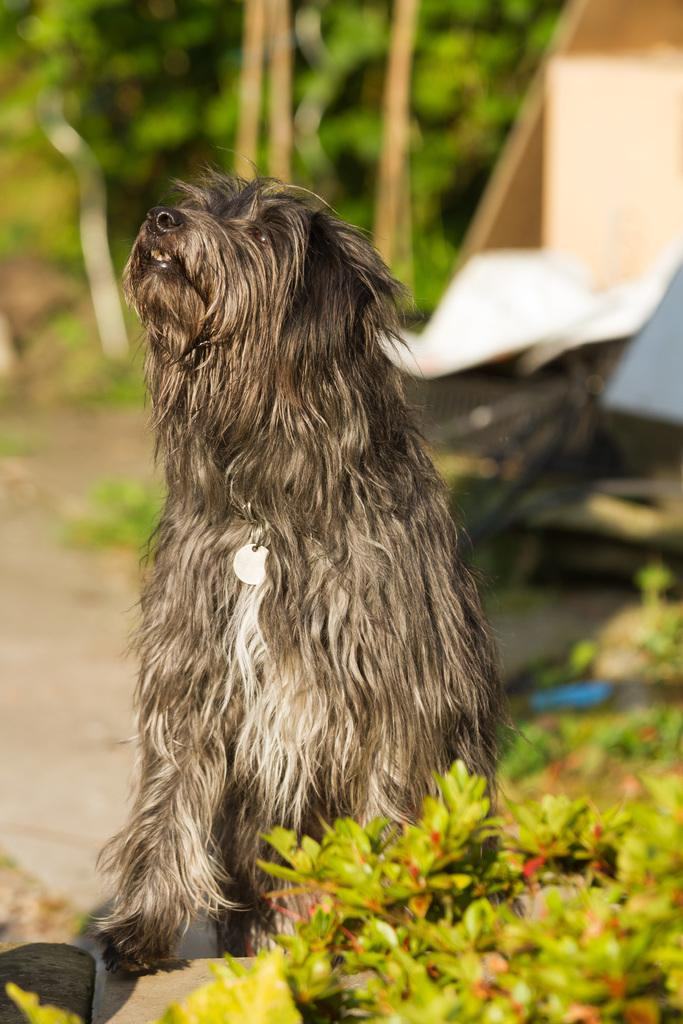What type of animal is present in the image? There is a dog in the image. What is located beside the dog in the image? There are plants beside the dog in the image. What type of liquid is the dog drinking in the image? There is no liquid present in the image; the dog is not shown drinking anything. 